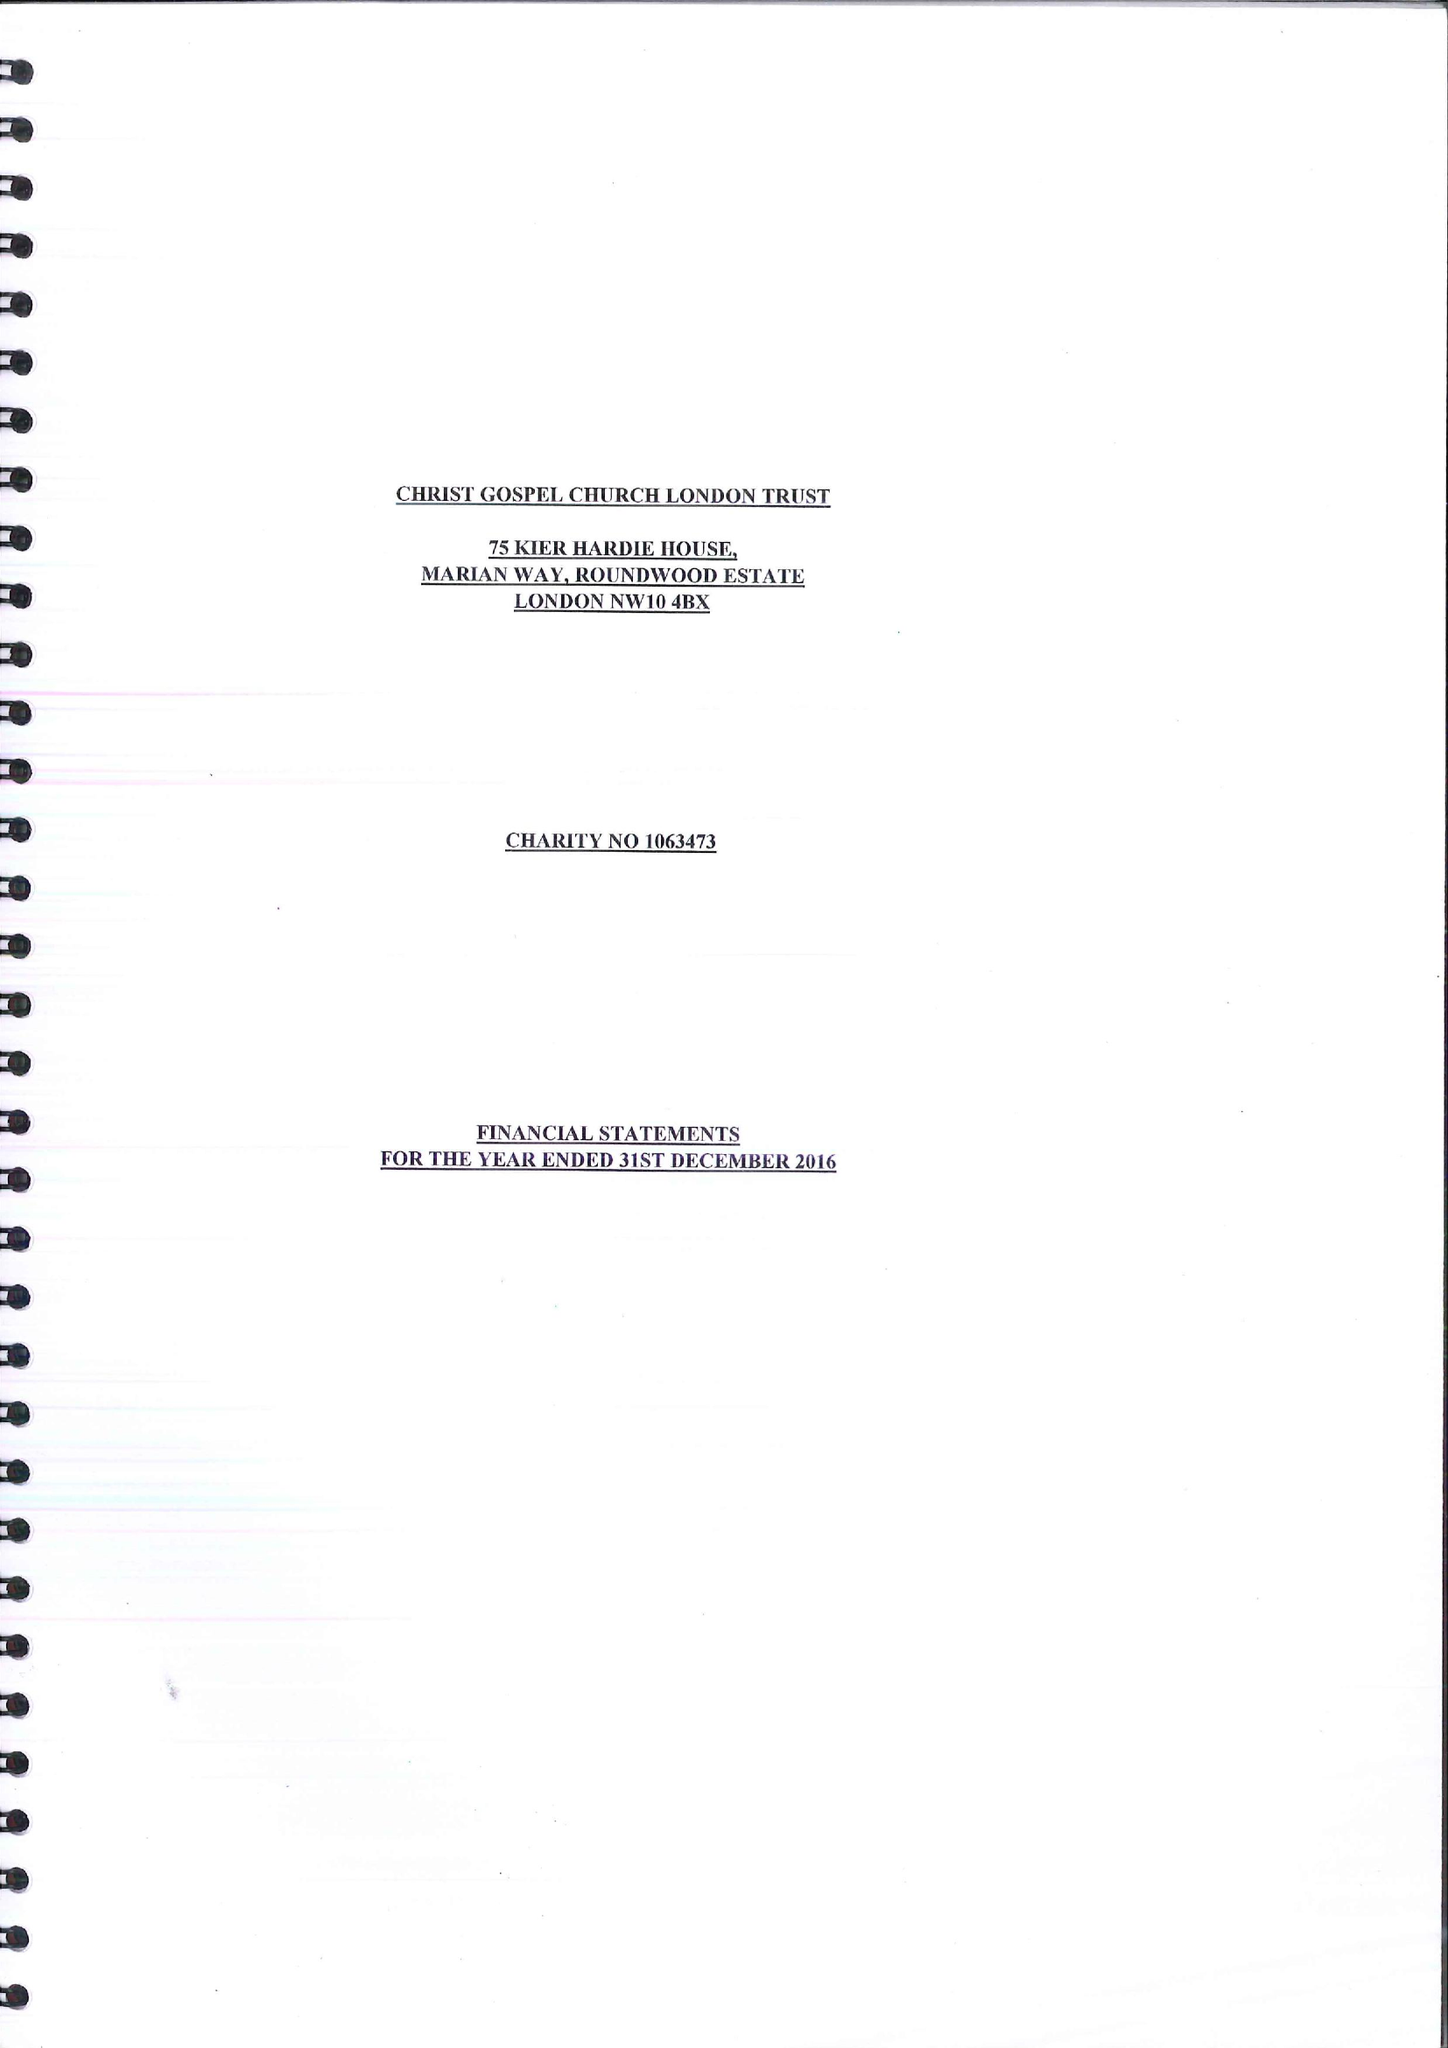What is the value for the spending_annually_in_british_pounds?
Answer the question using a single word or phrase. 29787.00 